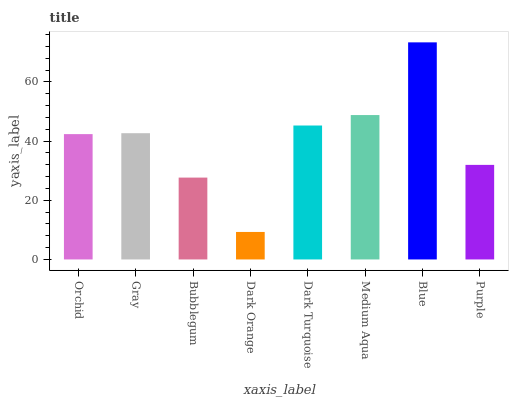Is Dark Orange the minimum?
Answer yes or no. Yes. Is Blue the maximum?
Answer yes or no. Yes. Is Gray the minimum?
Answer yes or no. No. Is Gray the maximum?
Answer yes or no. No. Is Gray greater than Orchid?
Answer yes or no. Yes. Is Orchid less than Gray?
Answer yes or no. Yes. Is Orchid greater than Gray?
Answer yes or no. No. Is Gray less than Orchid?
Answer yes or no. No. Is Gray the high median?
Answer yes or no. Yes. Is Orchid the low median?
Answer yes or no. Yes. Is Bubblegum the high median?
Answer yes or no. No. Is Gray the low median?
Answer yes or no. No. 